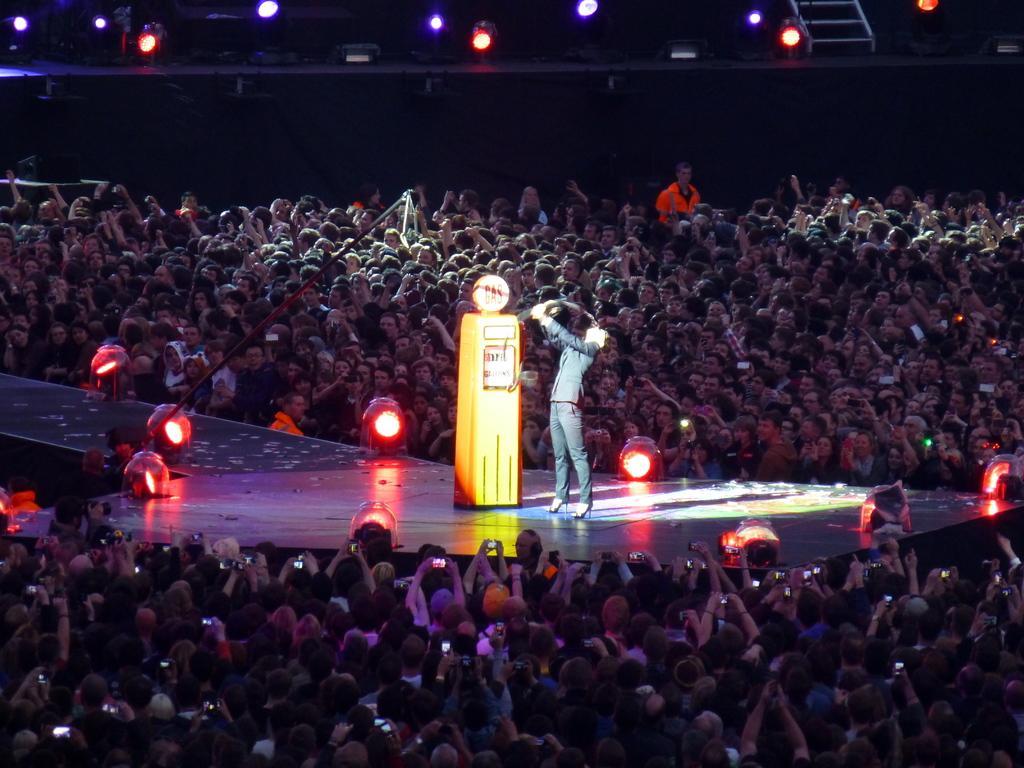Can you describe this image briefly? This image is taken indoors. In this image there are many people standing on the floor and a few are holding mobile phones in their hands. In the middle of the image there is a dais. There are a few lights and a woman is standing on the dais. At the top of the image there are a few lights. In this image the background is dark. 